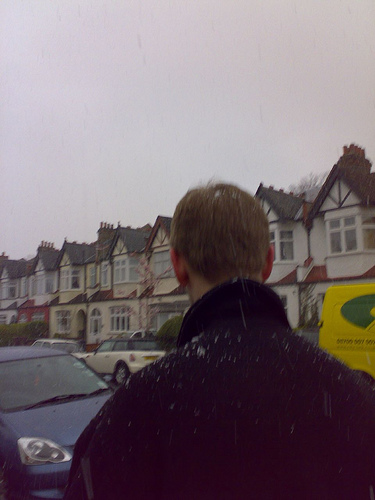<image>
Can you confirm if the home is behind the man? No. The home is not behind the man. From this viewpoint, the home appears to be positioned elsewhere in the scene. 